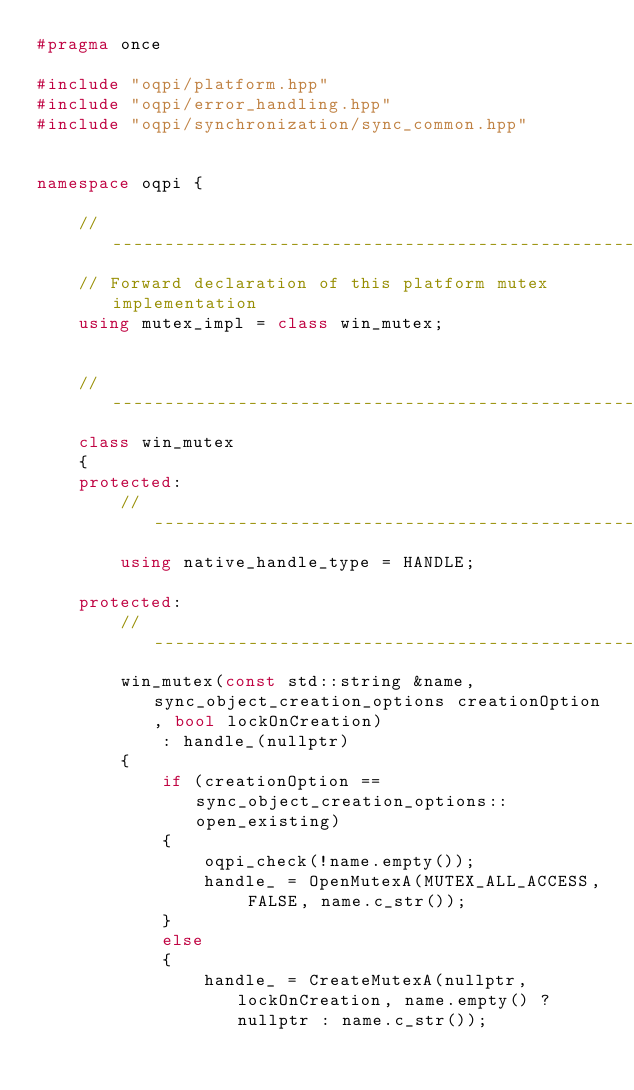Convert code to text. <code><loc_0><loc_0><loc_500><loc_500><_C++_>#pragma once

#include "oqpi/platform.hpp"
#include "oqpi/error_handling.hpp"
#include "oqpi/synchronization/sync_common.hpp"


namespace oqpi {

    //----------------------------------------------------------------------------------------------
    // Forward declaration of this platform mutex implementation
    using mutex_impl = class win_mutex;


    //----------------------------------------------------------------------------------------------
    class win_mutex
    {
    protected:
        //------------------------------------------------------------------------------------------
        using native_handle_type = HANDLE;

    protected:
        //------------------------------------------------------------------------------------------
        win_mutex(const std::string &name, sync_object_creation_options creationOption, bool lockOnCreation)
            : handle_(nullptr)
        {
            if (creationOption == sync_object_creation_options::open_existing)
            {
                oqpi_check(!name.empty());
                handle_ = OpenMutexA(MUTEX_ALL_ACCESS, FALSE, name.c_str());
            }
            else
            {
                handle_ = CreateMutexA(nullptr, lockOnCreation, name.empty() ? nullptr : name.c_str());</code> 